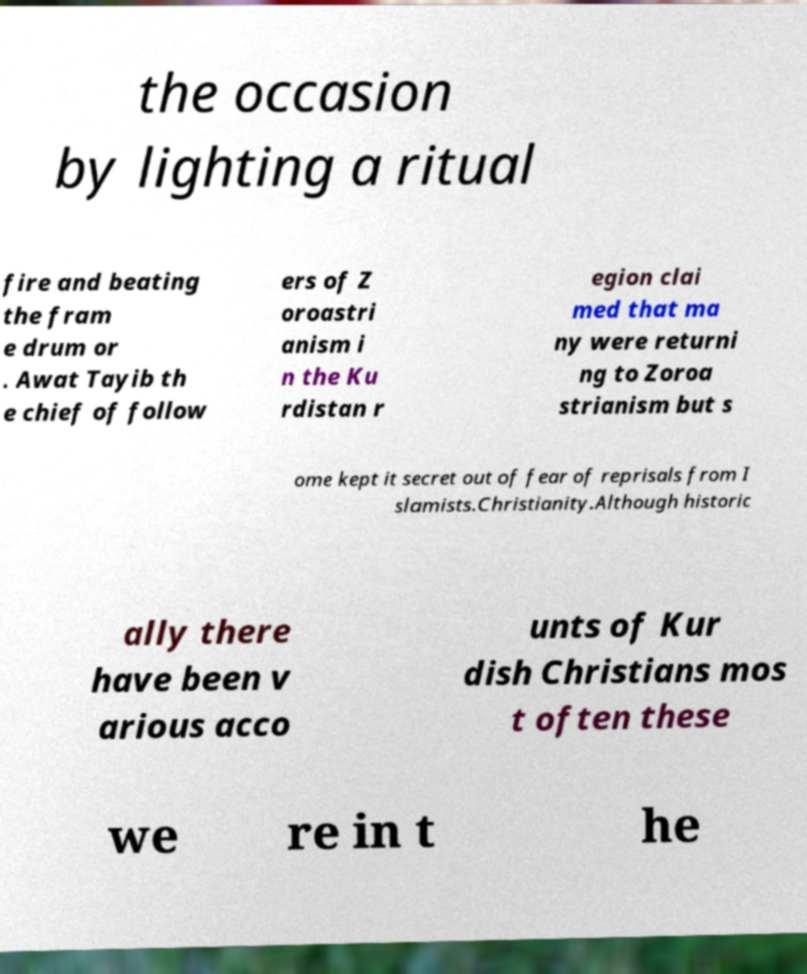Please read and relay the text visible in this image. What does it say? the occasion by lighting a ritual fire and beating the fram e drum or . Awat Tayib th e chief of follow ers of Z oroastri anism i n the Ku rdistan r egion clai med that ma ny were returni ng to Zoroa strianism but s ome kept it secret out of fear of reprisals from I slamists.Christianity.Although historic ally there have been v arious acco unts of Kur dish Christians mos t often these we re in t he 